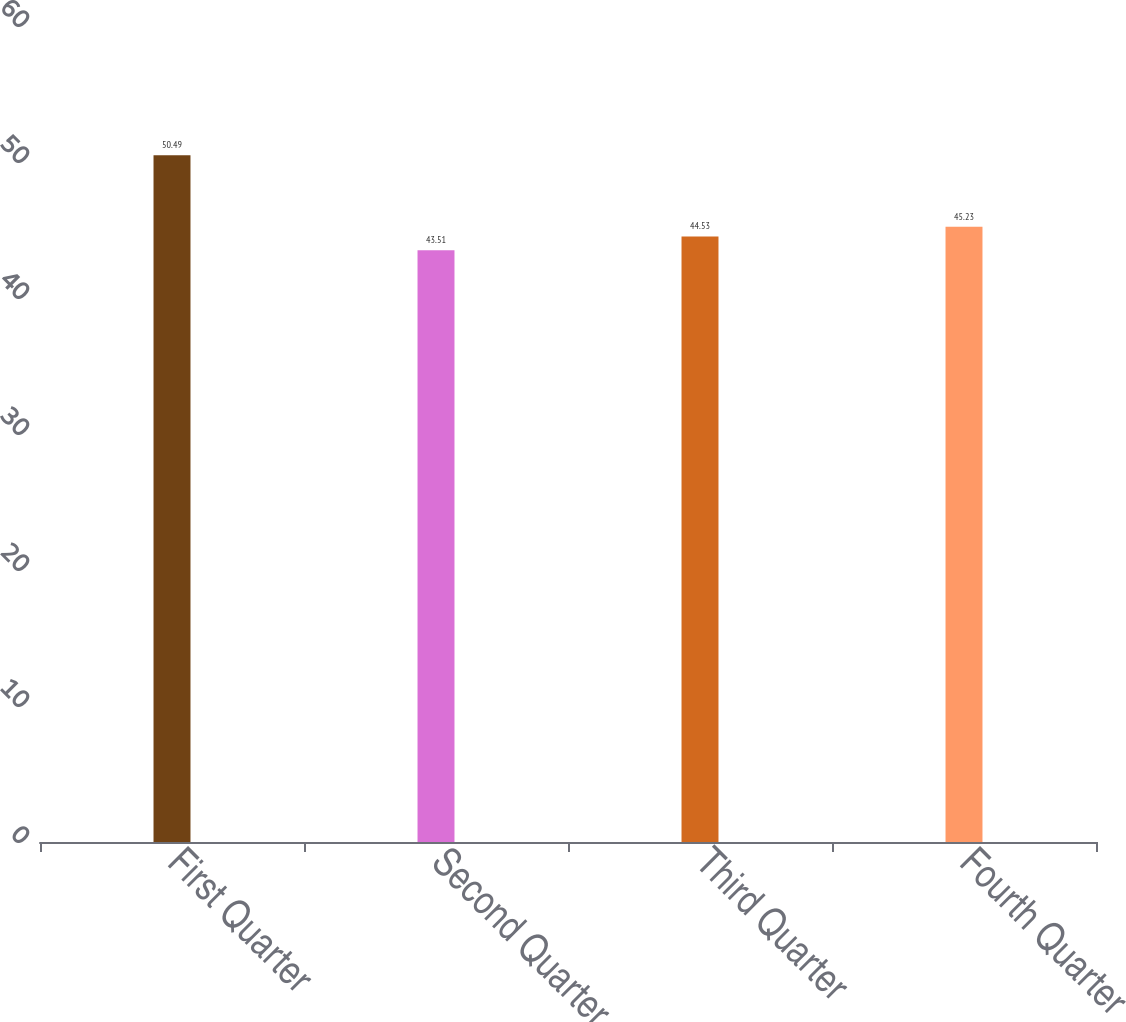<chart> <loc_0><loc_0><loc_500><loc_500><bar_chart><fcel>First Quarter<fcel>Second Quarter<fcel>Third Quarter<fcel>Fourth Quarter<nl><fcel>50.49<fcel>43.51<fcel>44.53<fcel>45.23<nl></chart> 